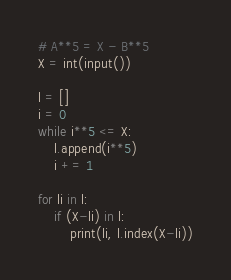<code> <loc_0><loc_0><loc_500><loc_500><_Python_># A**5 = X - B**5
X = int(input())

l = []
i = 0
while i**5 <= X:
    l.append(i**5)
    i += 1

for li in l:
    if (X-li) in l:
        print(li, l.index(X-li))</code> 